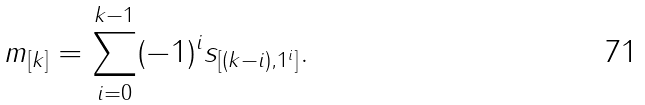<formula> <loc_0><loc_0><loc_500><loc_500>m _ { [ k ] } = \sum _ { i = 0 } ^ { k - 1 } ( - 1 ) ^ { i } s _ { [ ( k - i ) , 1 ^ { i } ] } .</formula> 